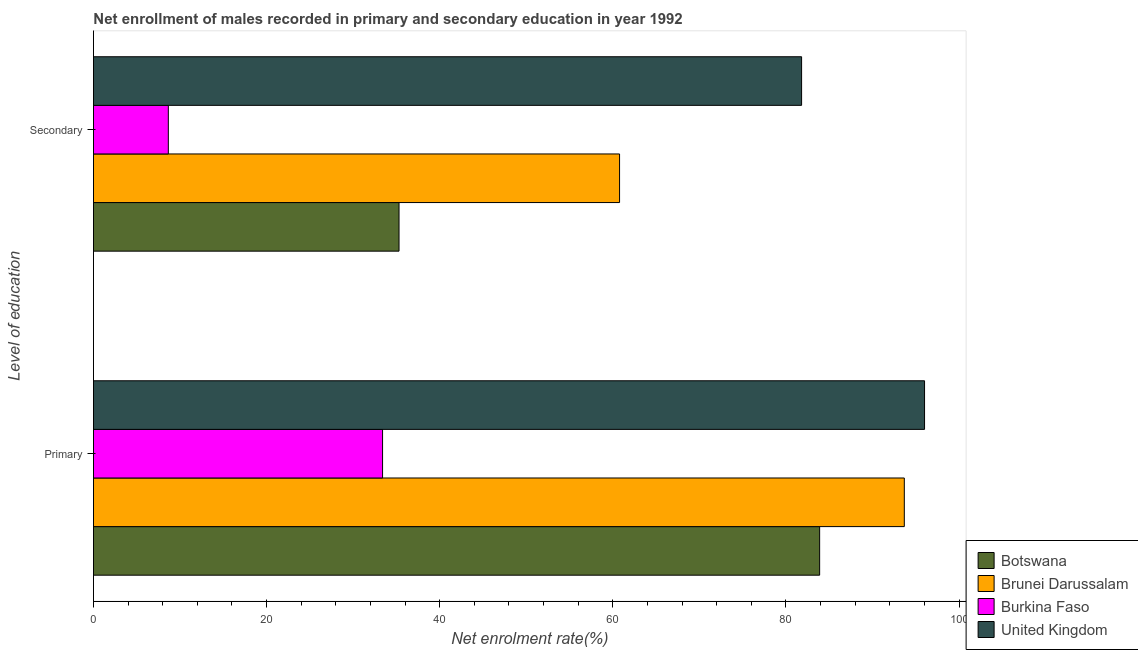How many different coloured bars are there?
Make the answer very short. 4. How many bars are there on the 1st tick from the top?
Provide a short and direct response. 4. What is the label of the 1st group of bars from the top?
Your response must be concise. Secondary. What is the enrollment rate in primary education in Brunei Darussalam?
Provide a succinct answer. 93.67. Across all countries, what is the maximum enrollment rate in secondary education?
Keep it short and to the point. 81.8. Across all countries, what is the minimum enrollment rate in secondary education?
Provide a succinct answer. 8.65. In which country was the enrollment rate in primary education minimum?
Your answer should be very brief. Burkina Faso. What is the total enrollment rate in secondary education in the graph?
Provide a short and direct response. 186.53. What is the difference between the enrollment rate in primary education in Burkina Faso and that in Botswana?
Your answer should be very brief. -50.49. What is the difference between the enrollment rate in secondary education in United Kingdom and the enrollment rate in primary education in Burkina Faso?
Make the answer very short. 48.41. What is the average enrollment rate in secondary education per country?
Your answer should be very brief. 46.63. What is the difference between the enrollment rate in primary education and enrollment rate in secondary education in Botswana?
Ensure brevity in your answer.  48.59. In how many countries, is the enrollment rate in secondary education greater than 32 %?
Give a very brief answer. 3. What is the ratio of the enrollment rate in secondary education in Burkina Faso to that in Botswana?
Offer a terse response. 0.25. Is the enrollment rate in primary education in Burkina Faso less than that in Botswana?
Keep it short and to the point. Yes. How many bars are there?
Ensure brevity in your answer.  8. How many countries are there in the graph?
Your response must be concise. 4. What is the difference between two consecutive major ticks on the X-axis?
Give a very brief answer. 20. Are the values on the major ticks of X-axis written in scientific E-notation?
Ensure brevity in your answer.  No. Does the graph contain grids?
Provide a succinct answer. No. Where does the legend appear in the graph?
Give a very brief answer. Bottom right. How are the legend labels stacked?
Give a very brief answer. Vertical. What is the title of the graph?
Your answer should be compact. Net enrollment of males recorded in primary and secondary education in year 1992. What is the label or title of the X-axis?
Provide a succinct answer. Net enrolment rate(%). What is the label or title of the Y-axis?
Offer a very short reply. Level of education. What is the Net enrolment rate(%) in Botswana in Primary?
Provide a succinct answer. 83.89. What is the Net enrolment rate(%) in Brunei Darussalam in Primary?
Offer a very short reply. 93.67. What is the Net enrolment rate(%) in Burkina Faso in Primary?
Provide a short and direct response. 33.4. What is the Net enrolment rate(%) of United Kingdom in Primary?
Provide a succinct answer. 96.01. What is the Net enrolment rate(%) in Botswana in Secondary?
Your response must be concise. 35.3. What is the Net enrolment rate(%) of Brunei Darussalam in Secondary?
Offer a terse response. 60.78. What is the Net enrolment rate(%) in Burkina Faso in Secondary?
Make the answer very short. 8.65. What is the Net enrolment rate(%) in United Kingdom in Secondary?
Keep it short and to the point. 81.8. Across all Level of education, what is the maximum Net enrolment rate(%) in Botswana?
Keep it short and to the point. 83.89. Across all Level of education, what is the maximum Net enrolment rate(%) of Brunei Darussalam?
Keep it short and to the point. 93.67. Across all Level of education, what is the maximum Net enrolment rate(%) of Burkina Faso?
Ensure brevity in your answer.  33.4. Across all Level of education, what is the maximum Net enrolment rate(%) in United Kingdom?
Offer a very short reply. 96.01. Across all Level of education, what is the minimum Net enrolment rate(%) of Botswana?
Keep it short and to the point. 35.3. Across all Level of education, what is the minimum Net enrolment rate(%) in Brunei Darussalam?
Your answer should be very brief. 60.78. Across all Level of education, what is the minimum Net enrolment rate(%) of Burkina Faso?
Keep it short and to the point. 8.65. Across all Level of education, what is the minimum Net enrolment rate(%) of United Kingdom?
Provide a succinct answer. 81.8. What is the total Net enrolment rate(%) in Botswana in the graph?
Offer a very short reply. 119.19. What is the total Net enrolment rate(%) of Brunei Darussalam in the graph?
Make the answer very short. 154.45. What is the total Net enrolment rate(%) in Burkina Faso in the graph?
Your answer should be compact. 42.04. What is the total Net enrolment rate(%) of United Kingdom in the graph?
Provide a succinct answer. 177.81. What is the difference between the Net enrolment rate(%) in Botswana in Primary and that in Secondary?
Provide a short and direct response. 48.59. What is the difference between the Net enrolment rate(%) in Brunei Darussalam in Primary and that in Secondary?
Your answer should be very brief. 32.89. What is the difference between the Net enrolment rate(%) in Burkina Faso in Primary and that in Secondary?
Keep it short and to the point. 24.75. What is the difference between the Net enrolment rate(%) in United Kingdom in Primary and that in Secondary?
Your response must be concise. 14.2. What is the difference between the Net enrolment rate(%) of Botswana in Primary and the Net enrolment rate(%) of Brunei Darussalam in Secondary?
Provide a short and direct response. 23.11. What is the difference between the Net enrolment rate(%) of Botswana in Primary and the Net enrolment rate(%) of Burkina Faso in Secondary?
Your answer should be compact. 75.24. What is the difference between the Net enrolment rate(%) in Botswana in Primary and the Net enrolment rate(%) in United Kingdom in Secondary?
Offer a very short reply. 2.08. What is the difference between the Net enrolment rate(%) in Brunei Darussalam in Primary and the Net enrolment rate(%) in Burkina Faso in Secondary?
Offer a very short reply. 85.02. What is the difference between the Net enrolment rate(%) of Brunei Darussalam in Primary and the Net enrolment rate(%) of United Kingdom in Secondary?
Give a very brief answer. 11.87. What is the difference between the Net enrolment rate(%) in Burkina Faso in Primary and the Net enrolment rate(%) in United Kingdom in Secondary?
Ensure brevity in your answer.  -48.41. What is the average Net enrolment rate(%) in Botswana per Level of education?
Make the answer very short. 59.59. What is the average Net enrolment rate(%) of Brunei Darussalam per Level of education?
Give a very brief answer. 77.22. What is the average Net enrolment rate(%) in Burkina Faso per Level of education?
Make the answer very short. 21.02. What is the average Net enrolment rate(%) in United Kingdom per Level of education?
Your answer should be compact. 88.91. What is the difference between the Net enrolment rate(%) of Botswana and Net enrolment rate(%) of Brunei Darussalam in Primary?
Make the answer very short. -9.78. What is the difference between the Net enrolment rate(%) of Botswana and Net enrolment rate(%) of Burkina Faso in Primary?
Keep it short and to the point. 50.49. What is the difference between the Net enrolment rate(%) of Botswana and Net enrolment rate(%) of United Kingdom in Primary?
Offer a terse response. -12.12. What is the difference between the Net enrolment rate(%) of Brunei Darussalam and Net enrolment rate(%) of Burkina Faso in Primary?
Offer a terse response. 60.27. What is the difference between the Net enrolment rate(%) in Brunei Darussalam and Net enrolment rate(%) in United Kingdom in Primary?
Make the answer very short. -2.34. What is the difference between the Net enrolment rate(%) of Burkina Faso and Net enrolment rate(%) of United Kingdom in Primary?
Your answer should be compact. -62.61. What is the difference between the Net enrolment rate(%) in Botswana and Net enrolment rate(%) in Brunei Darussalam in Secondary?
Provide a short and direct response. -25.48. What is the difference between the Net enrolment rate(%) of Botswana and Net enrolment rate(%) of Burkina Faso in Secondary?
Ensure brevity in your answer.  26.65. What is the difference between the Net enrolment rate(%) of Botswana and Net enrolment rate(%) of United Kingdom in Secondary?
Provide a short and direct response. -46.51. What is the difference between the Net enrolment rate(%) in Brunei Darussalam and Net enrolment rate(%) in Burkina Faso in Secondary?
Make the answer very short. 52.13. What is the difference between the Net enrolment rate(%) of Brunei Darussalam and Net enrolment rate(%) of United Kingdom in Secondary?
Offer a terse response. -21.03. What is the difference between the Net enrolment rate(%) in Burkina Faso and Net enrolment rate(%) in United Kingdom in Secondary?
Offer a very short reply. -73.16. What is the ratio of the Net enrolment rate(%) of Botswana in Primary to that in Secondary?
Give a very brief answer. 2.38. What is the ratio of the Net enrolment rate(%) of Brunei Darussalam in Primary to that in Secondary?
Make the answer very short. 1.54. What is the ratio of the Net enrolment rate(%) in Burkina Faso in Primary to that in Secondary?
Provide a succinct answer. 3.86. What is the ratio of the Net enrolment rate(%) in United Kingdom in Primary to that in Secondary?
Your answer should be compact. 1.17. What is the difference between the highest and the second highest Net enrolment rate(%) of Botswana?
Offer a terse response. 48.59. What is the difference between the highest and the second highest Net enrolment rate(%) in Brunei Darussalam?
Provide a succinct answer. 32.89. What is the difference between the highest and the second highest Net enrolment rate(%) in Burkina Faso?
Provide a short and direct response. 24.75. What is the difference between the highest and the second highest Net enrolment rate(%) of United Kingdom?
Keep it short and to the point. 14.2. What is the difference between the highest and the lowest Net enrolment rate(%) of Botswana?
Your answer should be compact. 48.59. What is the difference between the highest and the lowest Net enrolment rate(%) of Brunei Darussalam?
Provide a short and direct response. 32.89. What is the difference between the highest and the lowest Net enrolment rate(%) in Burkina Faso?
Provide a short and direct response. 24.75. What is the difference between the highest and the lowest Net enrolment rate(%) in United Kingdom?
Your answer should be very brief. 14.2. 